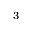<formula> <loc_0><loc_0><loc_500><loc_500>^ { 3 }</formula> 